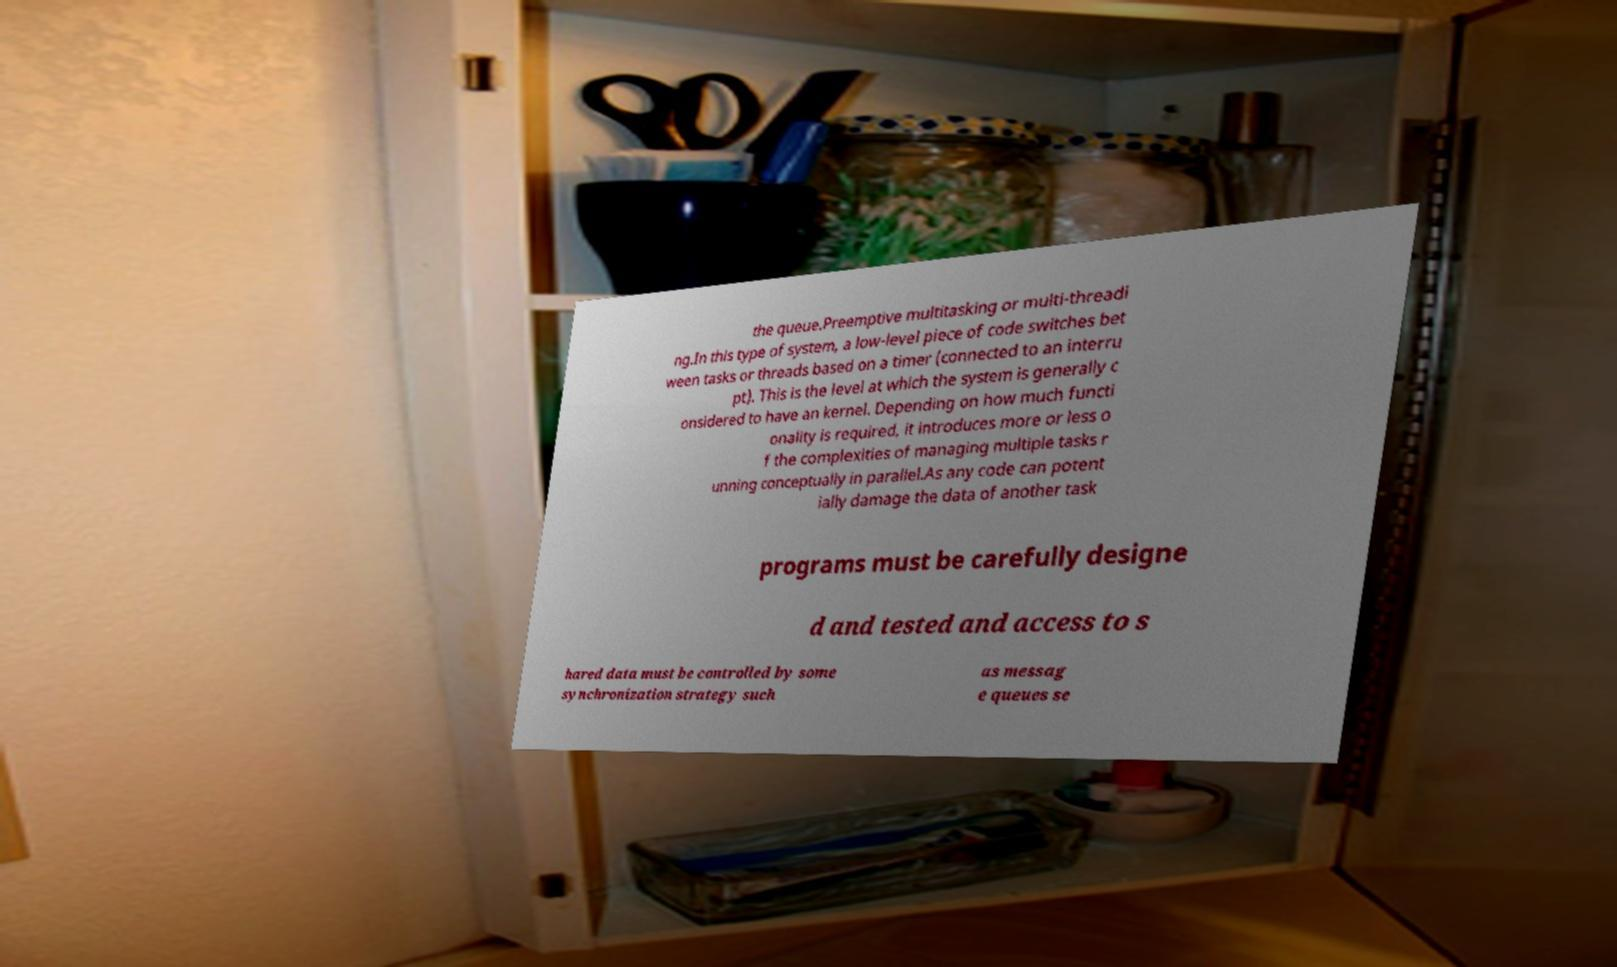Could you assist in decoding the text presented in this image and type it out clearly? the queue.Preemptive multitasking or multi-threadi ng.In this type of system, a low-level piece of code switches bet ween tasks or threads based on a timer (connected to an interru pt). This is the level at which the system is generally c onsidered to have an kernel. Depending on how much functi onality is required, it introduces more or less o f the complexities of managing multiple tasks r unning conceptually in parallel.As any code can potent ially damage the data of another task programs must be carefully designe d and tested and access to s hared data must be controlled by some synchronization strategy such as messag e queues se 